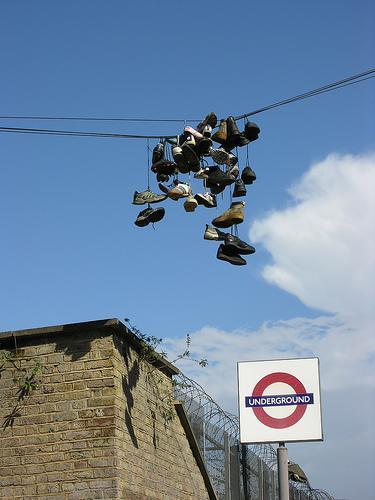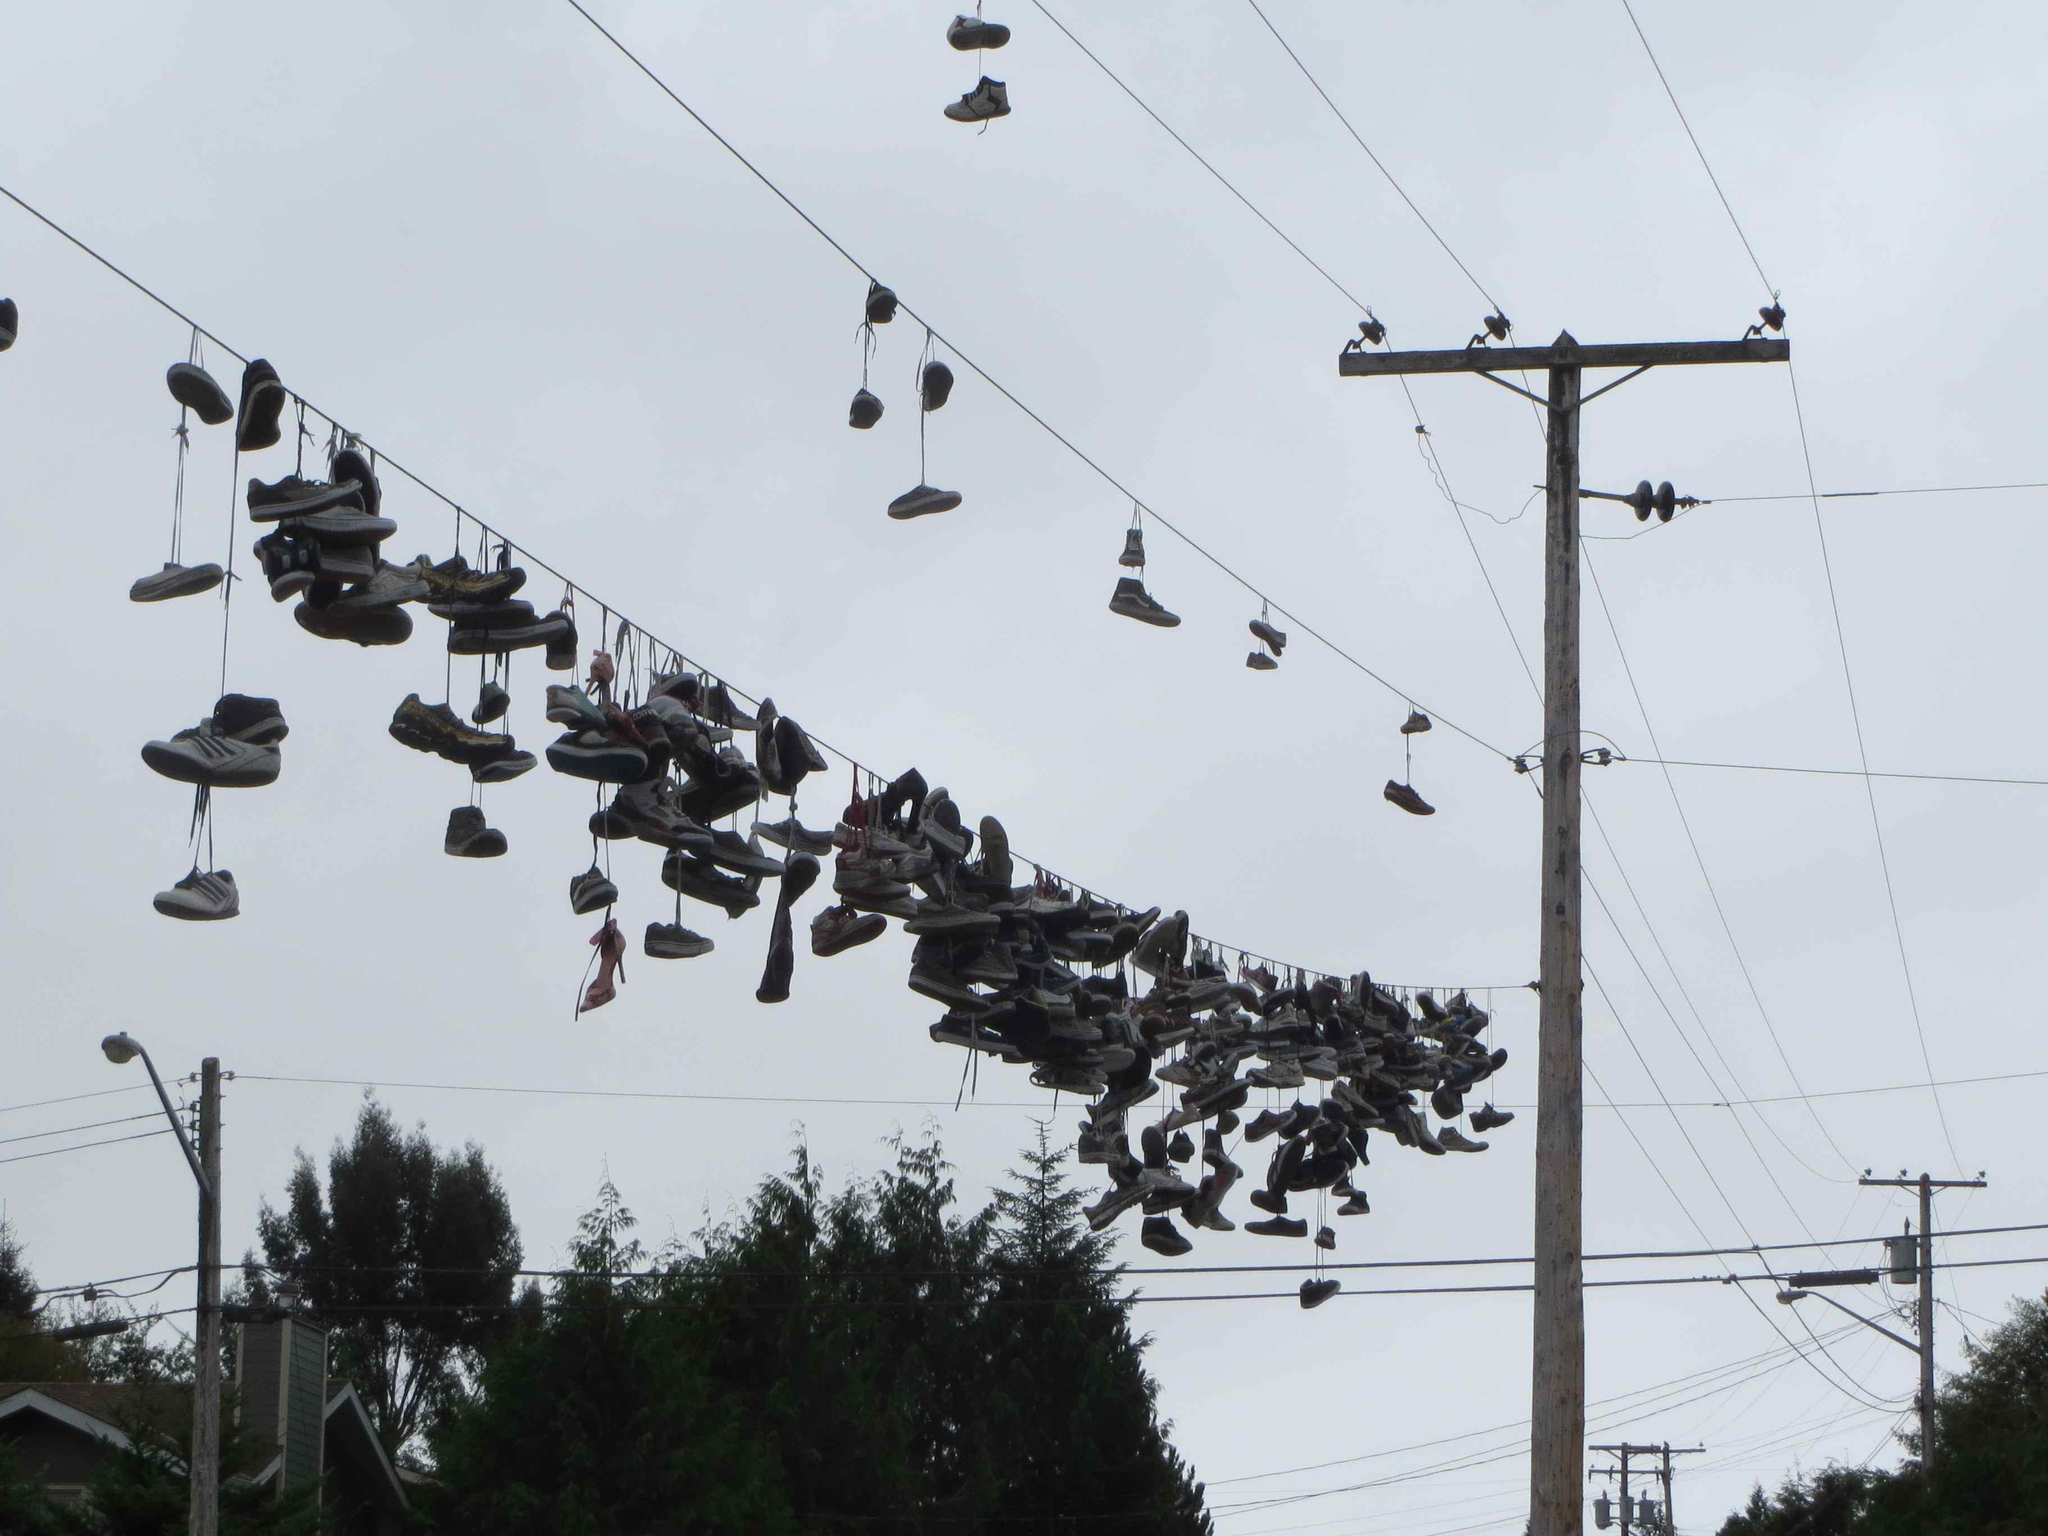The first image is the image on the left, the second image is the image on the right. Analyze the images presented: Is the assertion "Multiple pairs of shoes are hanging from the power lines in at least one picture." valid? Answer yes or no. Yes. The first image is the image on the left, the second image is the image on the right. Considering the images on both sides, is "There are no more than 2 pairs of shoes hanging from a power line." valid? Answer yes or no. No. 